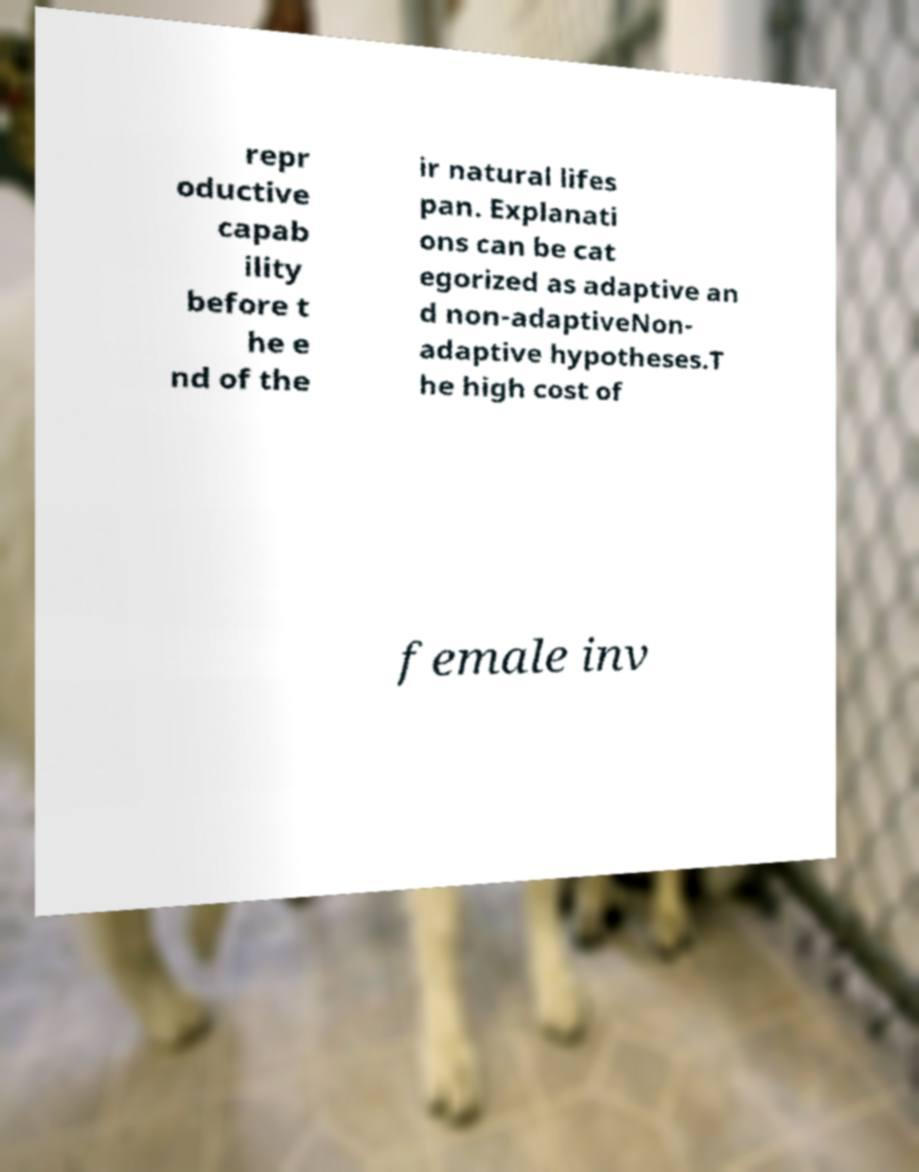What messages or text are displayed in this image? I need them in a readable, typed format. repr oductive capab ility before t he e nd of the ir natural lifes pan. Explanati ons can be cat egorized as adaptive an d non-adaptiveNon- adaptive hypotheses.T he high cost of female inv 